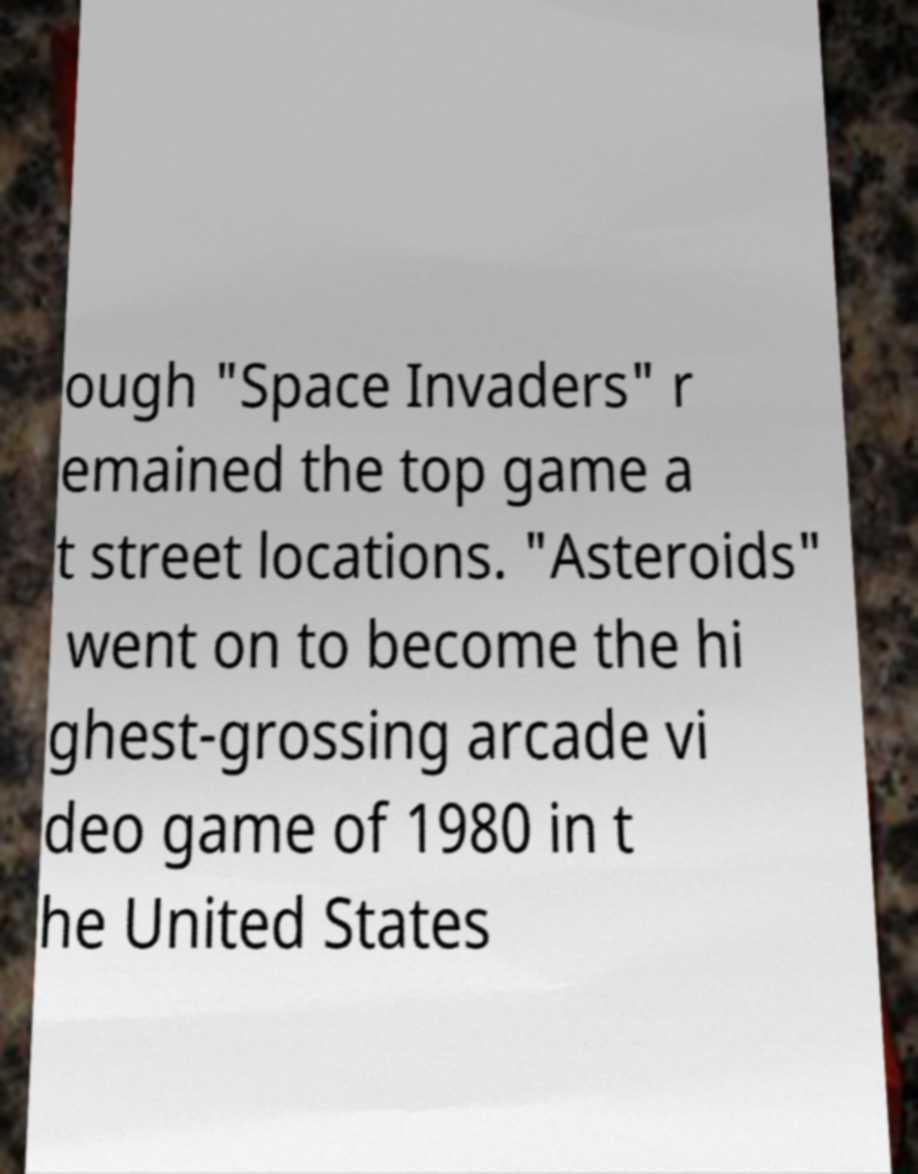For documentation purposes, I need the text within this image transcribed. Could you provide that? ough "Space Invaders" r emained the top game a t street locations. "Asteroids" went on to become the hi ghest-grossing arcade vi deo game of 1980 in t he United States 